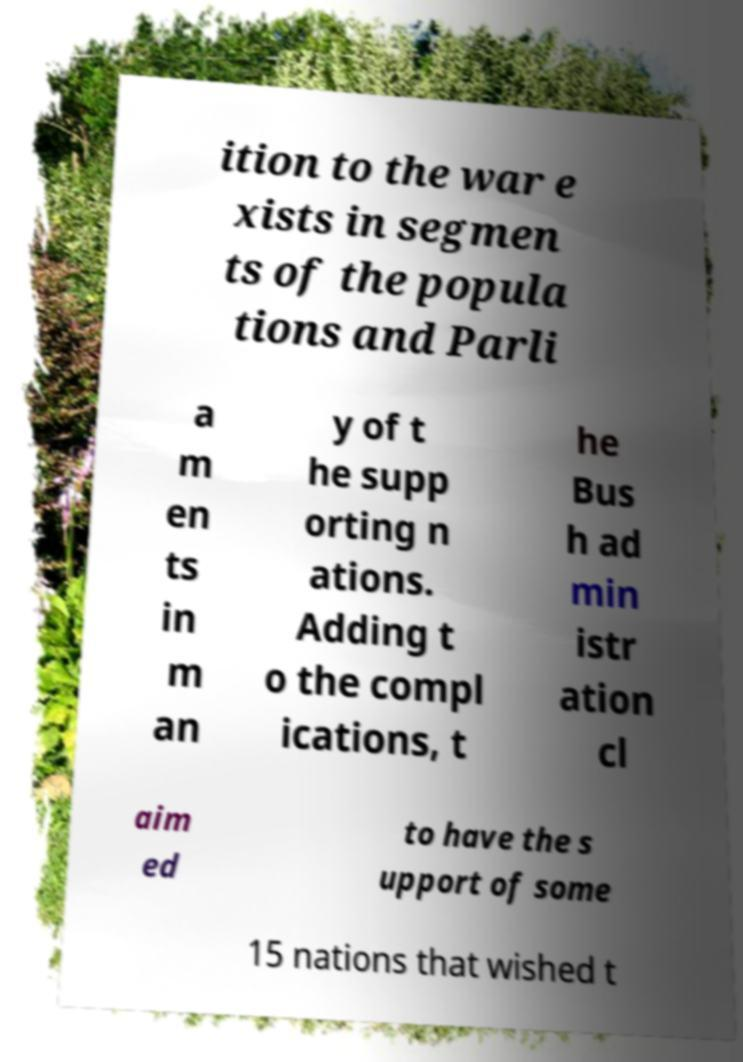What messages or text are displayed in this image? I need them in a readable, typed format. ition to the war e xists in segmen ts of the popula tions and Parli a m en ts in m an y of t he supp orting n ations. Adding t o the compl ications, t he Bus h ad min istr ation cl aim ed to have the s upport of some 15 nations that wished t 